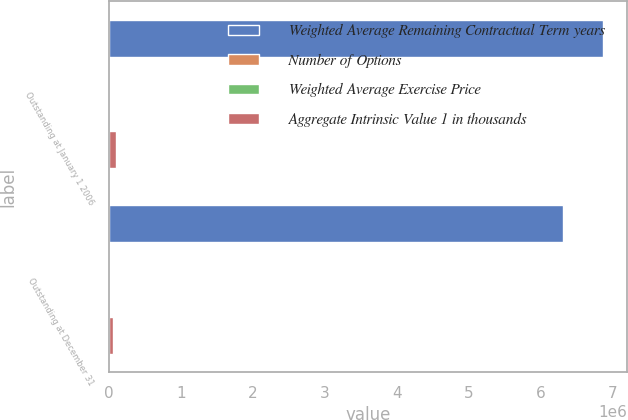Convert chart. <chart><loc_0><loc_0><loc_500><loc_500><stacked_bar_chart><ecel><fcel>Outstanding at January 1 2006<fcel>Outstanding at December 31<nl><fcel>Weighted Average Remaining Contractual Term years<fcel>6.85813e+06<fcel>6.30755e+06<nl><fcel>Number of Options<fcel>30<fcel>32.85<nl><fcel>Weighted Average Exercise Price<fcel>5.54<fcel>5.41<nl><fcel>Aggregate Intrinsic Value 1 in thousands<fcel>103283<fcel>65035<nl></chart> 